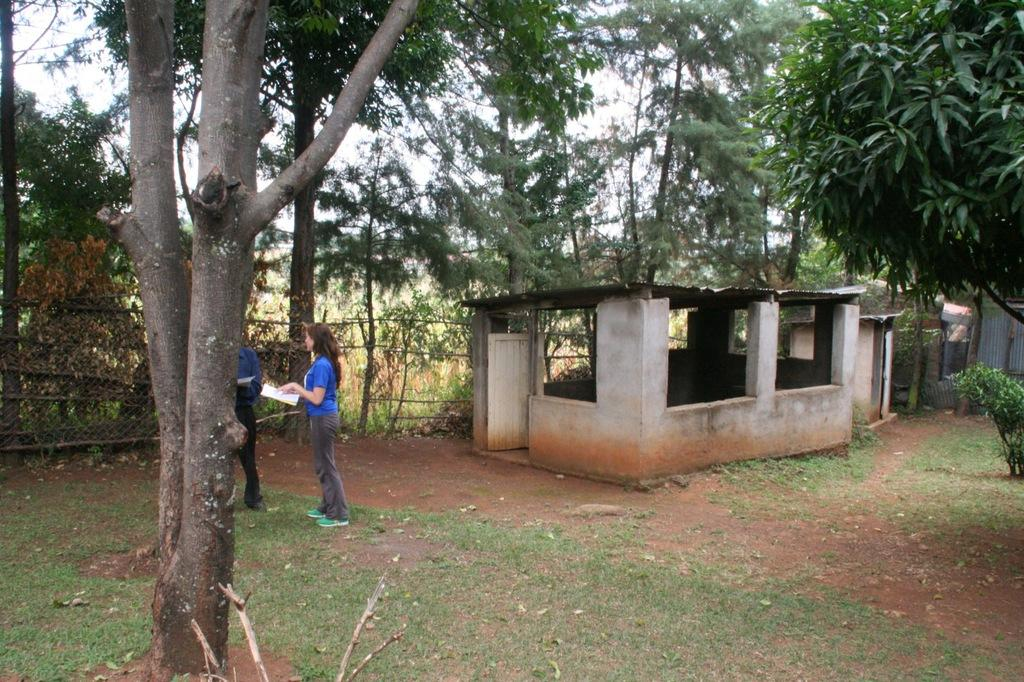How many people are present in the image? There are two people in the image. What can be seen in the background of the image? There is a building, trees, and a fence in the background of the image. What type of spoon is being used by the army in the image? There is no army or spoon present in the image. 